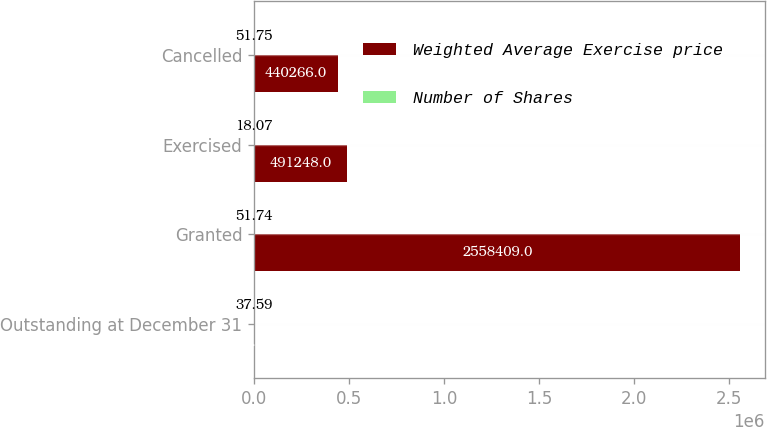Convert chart to OTSL. <chart><loc_0><loc_0><loc_500><loc_500><stacked_bar_chart><ecel><fcel>Outstanding at December 31<fcel>Granted<fcel>Exercised<fcel>Cancelled<nl><fcel>Weighted Average Exercise price<fcel>51.75<fcel>2.55841e+06<fcel>491248<fcel>440266<nl><fcel>Number of Shares<fcel>37.59<fcel>51.74<fcel>18.07<fcel>51.75<nl></chart> 